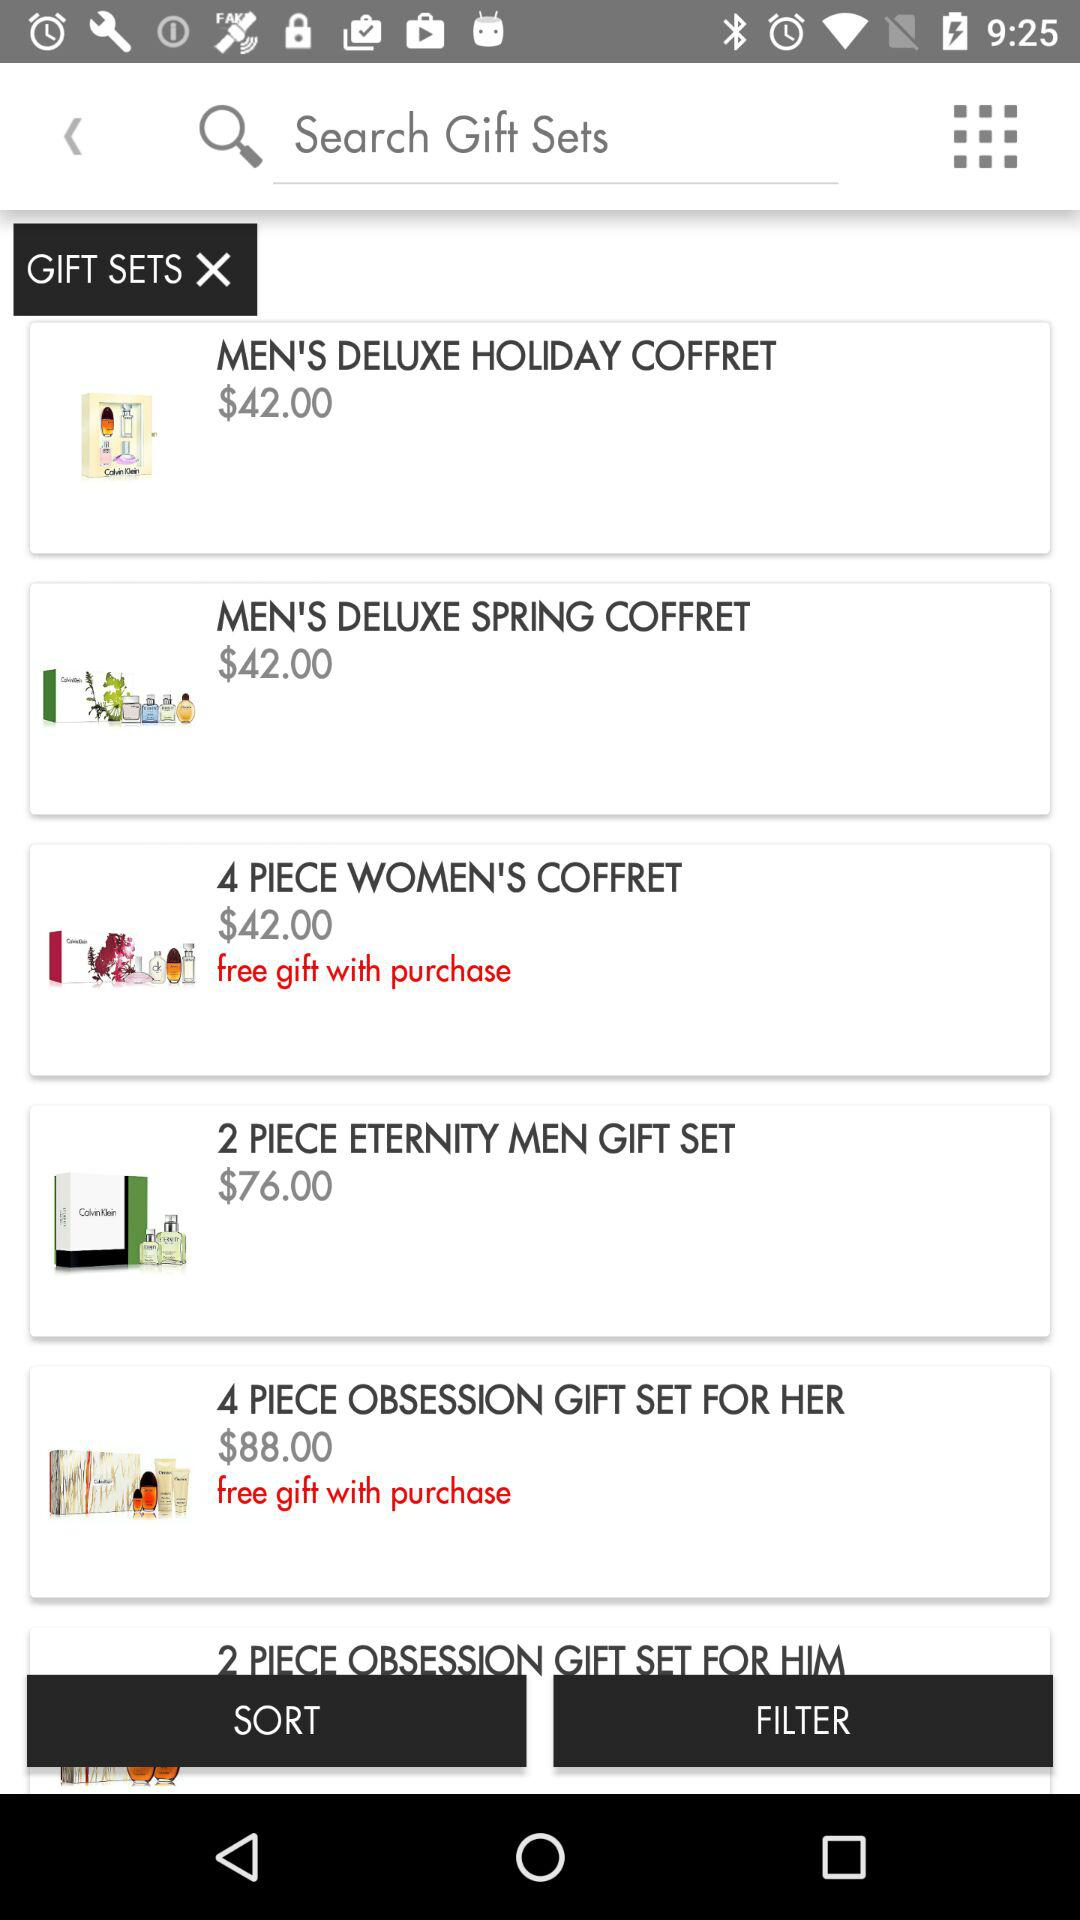For which items are free gifts available? The items for which free gifts are available are "4 PIECE WOMEN'S COFFRET" and "4 PIECE OBSESSION GIFT SET FOR HER". 